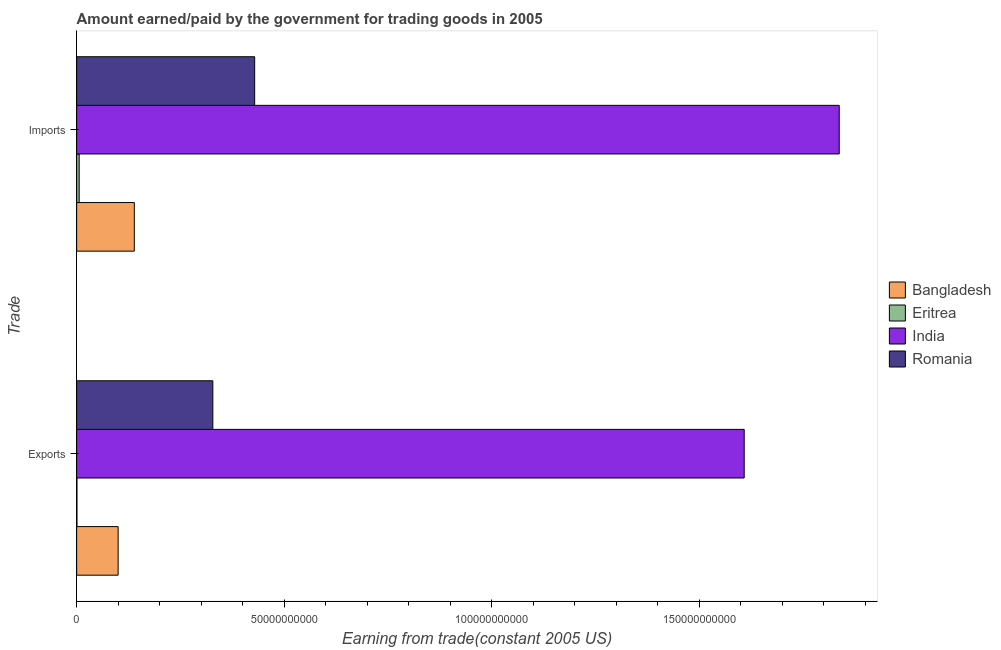How many different coloured bars are there?
Your answer should be compact. 4. Are the number of bars on each tick of the Y-axis equal?
Your answer should be very brief. Yes. How many bars are there on the 1st tick from the top?
Give a very brief answer. 4. What is the label of the 1st group of bars from the top?
Your answer should be very brief. Imports. What is the amount paid for imports in Romania?
Make the answer very short. 4.29e+1. Across all countries, what is the maximum amount earned from exports?
Ensure brevity in your answer.  1.61e+11. Across all countries, what is the minimum amount paid for imports?
Provide a succinct answer. 6.03e+08. In which country was the amount paid for imports maximum?
Provide a succinct answer. India. In which country was the amount paid for imports minimum?
Make the answer very short. Eritrea. What is the total amount paid for imports in the graph?
Provide a succinct answer. 2.41e+11. What is the difference between the amount earned from exports in Romania and that in India?
Offer a terse response. -1.28e+11. What is the difference between the amount paid for imports in India and the amount earned from exports in Bangladesh?
Offer a terse response. 1.74e+11. What is the average amount earned from exports per country?
Offer a terse response. 5.09e+1. What is the difference between the amount earned from exports and amount paid for imports in Romania?
Your answer should be compact. -1.01e+1. What is the ratio of the amount paid for imports in Eritrea to that in India?
Keep it short and to the point. 0. Is the amount paid for imports in Eritrea less than that in Romania?
Provide a short and direct response. Yes. In how many countries, is the amount paid for imports greater than the average amount paid for imports taken over all countries?
Your answer should be compact. 1. What does the 3rd bar from the top in Exports represents?
Your answer should be very brief. Eritrea. What does the 4th bar from the bottom in Imports represents?
Your answer should be compact. Romania. How many bars are there?
Ensure brevity in your answer.  8. Are all the bars in the graph horizontal?
Your response must be concise. Yes. What is the difference between two consecutive major ticks on the X-axis?
Provide a succinct answer. 5.00e+1. Does the graph contain any zero values?
Ensure brevity in your answer.  No. Does the graph contain grids?
Give a very brief answer. No. What is the title of the graph?
Your answer should be compact. Amount earned/paid by the government for trading goods in 2005. What is the label or title of the X-axis?
Make the answer very short. Earning from trade(constant 2005 US). What is the label or title of the Y-axis?
Your answer should be very brief. Trade. What is the Earning from trade(constant 2005 US) in Bangladesh in Exports?
Provide a short and direct response. 9.99e+09. What is the Earning from trade(constant 2005 US) in Eritrea in Exports?
Offer a very short reply. 6.77e+07. What is the Earning from trade(constant 2005 US) of India in Exports?
Offer a terse response. 1.61e+11. What is the Earning from trade(constant 2005 US) in Romania in Exports?
Your response must be concise. 3.28e+1. What is the Earning from trade(constant 2005 US) in Bangladesh in Imports?
Your answer should be compact. 1.39e+1. What is the Earning from trade(constant 2005 US) of Eritrea in Imports?
Offer a terse response. 6.03e+08. What is the Earning from trade(constant 2005 US) in India in Imports?
Keep it short and to the point. 1.84e+11. What is the Earning from trade(constant 2005 US) of Romania in Imports?
Your answer should be compact. 4.29e+1. Across all Trade, what is the maximum Earning from trade(constant 2005 US) of Bangladesh?
Provide a short and direct response. 1.39e+1. Across all Trade, what is the maximum Earning from trade(constant 2005 US) of Eritrea?
Give a very brief answer. 6.03e+08. Across all Trade, what is the maximum Earning from trade(constant 2005 US) in India?
Offer a very short reply. 1.84e+11. Across all Trade, what is the maximum Earning from trade(constant 2005 US) in Romania?
Provide a succinct answer. 4.29e+1. Across all Trade, what is the minimum Earning from trade(constant 2005 US) in Bangladesh?
Provide a succinct answer. 9.99e+09. Across all Trade, what is the minimum Earning from trade(constant 2005 US) in Eritrea?
Provide a succinct answer. 6.77e+07. Across all Trade, what is the minimum Earning from trade(constant 2005 US) in India?
Provide a short and direct response. 1.61e+11. Across all Trade, what is the minimum Earning from trade(constant 2005 US) in Romania?
Keep it short and to the point. 3.28e+1. What is the total Earning from trade(constant 2005 US) in Bangladesh in the graph?
Offer a very short reply. 2.39e+1. What is the total Earning from trade(constant 2005 US) in Eritrea in the graph?
Provide a succinct answer. 6.71e+08. What is the total Earning from trade(constant 2005 US) of India in the graph?
Offer a terse response. 3.45e+11. What is the total Earning from trade(constant 2005 US) of Romania in the graph?
Your answer should be very brief. 7.57e+1. What is the difference between the Earning from trade(constant 2005 US) of Bangladesh in Exports and that in Imports?
Offer a very short reply. -3.90e+09. What is the difference between the Earning from trade(constant 2005 US) of Eritrea in Exports and that in Imports?
Keep it short and to the point. -5.36e+08. What is the difference between the Earning from trade(constant 2005 US) of India in Exports and that in Imports?
Provide a succinct answer. -2.29e+1. What is the difference between the Earning from trade(constant 2005 US) of Romania in Exports and that in Imports?
Offer a terse response. -1.01e+1. What is the difference between the Earning from trade(constant 2005 US) in Bangladesh in Exports and the Earning from trade(constant 2005 US) in Eritrea in Imports?
Provide a succinct answer. 9.39e+09. What is the difference between the Earning from trade(constant 2005 US) of Bangladesh in Exports and the Earning from trade(constant 2005 US) of India in Imports?
Offer a terse response. -1.74e+11. What is the difference between the Earning from trade(constant 2005 US) in Bangladesh in Exports and the Earning from trade(constant 2005 US) in Romania in Imports?
Provide a short and direct response. -3.29e+1. What is the difference between the Earning from trade(constant 2005 US) in Eritrea in Exports and the Earning from trade(constant 2005 US) in India in Imports?
Your answer should be compact. -1.84e+11. What is the difference between the Earning from trade(constant 2005 US) of Eritrea in Exports and the Earning from trade(constant 2005 US) of Romania in Imports?
Provide a succinct answer. -4.28e+1. What is the difference between the Earning from trade(constant 2005 US) of India in Exports and the Earning from trade(constant 2005 US) of Romania in Imports?
Your answer should be compact. 1.18e+11. What is the average Earning from trade(constant 2005 US) of Bangladesh per Trade?
Offer a terse response. 1.19e+1. What is the average Earning from trade(constant 2005 US) of Eritrea per Trade?
Keep it short and to the point. 3.36e+08. What is the average Earning from trade(constant 2005 US) in India per Trade?
Keep it short and to the point. 1.72e+11. What is the average Earning from trade(constant 2005 US) in Romania per Trade?
Keep it short and to the point. 3.78e+1. What is the difference between the Earning from trade(constant 2005 US) in Bangladesh and Earning from trade(constant 2005 US) in Eritrea in Exports?
Your answer should be compact. 9.93e+09. What is the difference between the Earning from trade(constant 2005 US) of Bangladesh and Earning from trade(constant 2005 US) of India in Exports?
Offer a terse response. -1.51e+11. What is the difference between the Earning from trade(constant 2005 US) of Bangladesh and Earning from trade(constant 2005 US) of Romania in Exports?
Your response must be concise. -2.28e+1. What is the difference between the Earning from trade(constant 2005 US) in Eritrea and Earning from trade(constant 2005 US) in India in Exports?
Your answer should be compact. -1.61e+11. What is the difference between the Earning from trade(constant 2005 US) of Eritrea and Earning from trade(constant 2005 US) of Romania in Exports?
Provide a succinct answer. -3.27e+1. What is the difference between the Earning from trade(constant 2005 US) of India and Earning from trade(constant 2005 US) of Romania in Exports?
Make the answer very short. 1.28e+11. What is the difference between the Earning from trade(constant 2005 US) in Bangladesh and Earning from trade(constant 2005 US) in Eritrea in Imports?
Make the answer very short. 1.33e+1. What is the difference between the Earning from trade(constant 2005 US) in Bangladesh and Earning from trade(constant 2005 US) in India in Imports?
Keep it short and to the point. -1.70e+11. What is the difference between the Earning from trade(constant 2005 US) in Bangladesh and Earning from trade(constant 2005 US) in Romania in Imports?
Provide a succinct answer. -2.90e+1. What is the difference between the Earning from trade(constant 2005 US) in Eritrea and Earning from trade(constant 2005 US) in India in Imports?
Give a very brief answer. -1.83e+11. What is the difference between the Earning from trade(constant 2005 US) in Eritrea and Earning from trade(constant 2005 US) in Romania in Imports?
Make the answer very short. -4.23e+1. What is the difference between the Earning from trade(constant 2005 US) of India and Earning from trade(constant 2005 US) of Romania in Imports?
Ensure brevity in your answer.  1.41e+11. What is the ratio of the Earning from trade(constant 2005 US) of Bangladesh in Exports to that in Imports?
Provide a short and direct response. 0.72. What is the ratio of the Earning from trade(constant 2005 US) in Eritrea in Exports to that in Imports?
Make the answer very short. 0.11. What is the ratio of the Earning from trade(constant 2005 US) in India in Exports to that in Imports?
Give a very brief answer. 0.88. What is the ratio of the Earning from trade(constant 2005 US) in Romania in Exports to that in Imports?
Your response must be concise. 0.77. What is the difference between the highest and the second highest Earning from trade(constant 2005 US) of Bangladesh?
Your answer should be very brief. 3.90e+09. What is the difference between the highest and the second highest Earning from trade(constant 2005 US) in Eritrea?
Ensure brevity in your answer.  5.36e+08. What is the difference between the highest and the second highest Earning from trade(constant 2005 US) in India?
Provide a short and direct response. 2.29e+1. What is the difference between the highest and the second highest Earning from trade(constant 2005 US) of Romania?
Keep it short and to the point. 1.01e+1. What is the difference between the highest and the lowest Earning from trade(constant 2005 US) in Bangladesh?
Offer a terse response. 3.90e+09. What is the difference between the highest and the lowest Earning from trade(constant 2005 US) of Eritrea?
Give a very brief answer. 5.36e+08. What is the difference between the highest and the lowest Earning from trade(constant 2005 US) in India?
Provide a short and direct response. 2.29e+1. What is the difference between the highest and the lowest Earning from trade(constant 2005 US) of Romania?
Keep it short and to the point. 1.01e+1. 